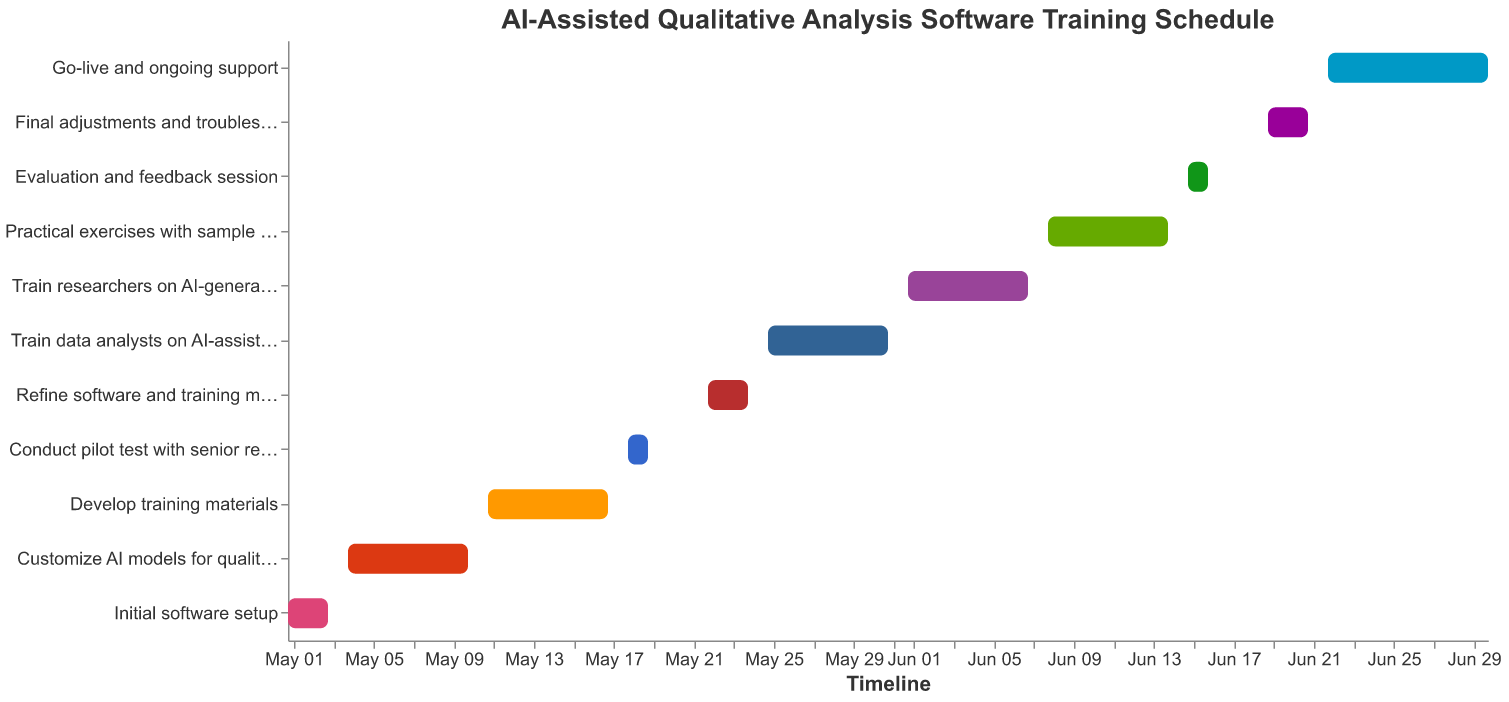What is the duration of the "Initial software setup" task? The "Initial software setup" task spans from May 1, 2023, to May 3, 2023. Hence, the duration is the difference between the start and end date (including both dates) which is 3 days.
Answer: 3 days How many tasks are scheduled to be completed by the end of May 2023? Tasks are: "Initial software setup", "Customize AI models for qualitative analysis", "Develop training materials", "Conduct pilot test with senior researchers", "Refine software and training materials", and "Train data analysts on AI-assisted coding". Each of these tasks ends before or on May 31, 2023, making the count 6 tasks in total.
Answer: 6 tasks Which task has the earliest start date and what is that date? The earliest start date is for the "Initial software setup" which begins on May 1, 2023. This is apparent by tracing the timelines from left to right.
Answer: May 1, 2023 Which task has the latest end date and what is that date? "Go-live and ongoing support" has the latest end date, extending till June 30, 2023.
Answer: June 30, 2023 Which task has the shortest duration and how long is it? Both "Conduct pilot test with senior researchers" and "Evaluation and feedback session" have the shortest duration, each lasting for 2 days.
Answer: 2 days How does the duration of "Develop training materials" compare to "Customize AI models for qualitative analysis"? "Develop training materials" and "Customize AI models for qualitative analysis" both have the same duration of 7 days.
Answer: They are equal When does "Final adjustments and troubleshooting" start and end? The task "Final adjustments and troubleshooting" starts on June 19, 2023, and ends on June 21, 2023. This information can be seen clearly in the timeline of the Gantt chart.
Answer: June 19, 2023 to June 21, 2023 How long is the gap between the end of "Conduct pilot test with senior researchers" and the start of "Refine software and training materials"? "Conduct pilot test with senior researchers" ends on May 19, 2023. "Refine software and training materials" starts on May 22, 2023. The gap is May 20 to May 21, which is 2 days.
Answer: 2 days What is the total duration of all tasks that occur in June 2023? Interpreting the durations of tasks wholly or partially in June: "Train researchers on AI-generated insights interpretation" (5 days), "Practical exercises with sample datasets" (5 days), "Evaluation and feedback session" (2 days), "Final adjustments and troubleshooting" (3 days), and "Go-live and ongoing support" (7 days). Summing these durations: 5 + 5 + 2 + 3 + 7 = 22 days.
Answer: 22 days 